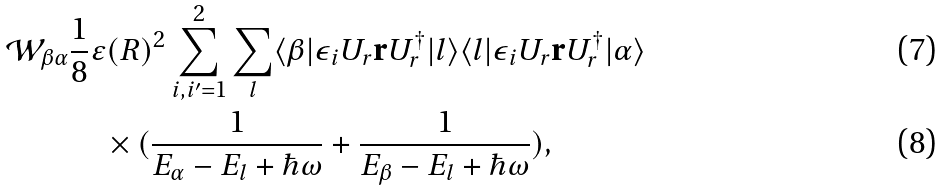<formula> <loc_0><loc_0><loc_500><loc_500>\mathcal { W } _ { \beta \alpha } & \frac { 1 } { 8 } \varepsilon ( R ) ^ { 2 } \sum _ { i , i ^ { \prime } = 1 } ^ { 2 } \sum _ { l } \langle \beta | \epsilon _ { i } U _ { r } \mathbf r U _ { r } ^ { \dagger } | l \rangle \langle l | \epsilon _ { i } U _ { r } \mathbf r U _ { r } ^ { \dagger } | \alpha \rangle \\ & \quad \times ( \frac { 1 } { E _ { \alpha } - E _ { l } + \hbar { \omega } } + \frac { 1 } { E _ { \beta } - E _ { l } + \hbar { \omega } } ) ,</formula> 